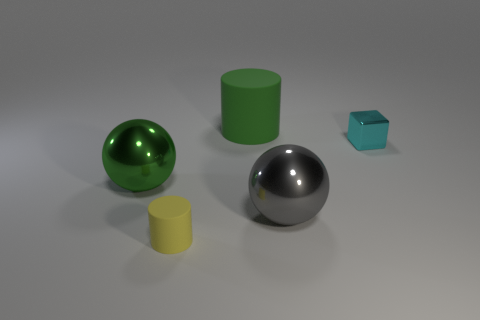There is a large green thing that is left of the small cylinder; what material is it?
Ensure brevity in your answer.  Metal. Is the material of the large green thing that is behind the cyan metallic thing the same as the small cyan cube?
Give a very brief answer. No. The green metal thing is what shape?
Keep it short and to the point. Sphere. There is a yellow matte cylinder in front of the green object right of the green metallic object; how many cylinders are to the left of it?
Offer a very short reply. 0. How many other objects are there of the same material as the gray sphere?
Your answer should be compact. 2. There is a gray object that is the same size as the green ball; what material is it?
Your answer should be very brief. Metal. Is the color of the sphere behind the big gray ball the same as the rubber cylinder behind the cyan block?
Provide a succinct answer. Yes. Is there another large rubber thing that has the same shape as the yellow matte thing?
Offer a very short reply. Yes. There is a shiny thing that is the same size as the gray shiny ball; what is its shape?
Keep it short and to the point. Sphere. How many large spheres have the same color as the large cylinder?
Your answer should be very brief. 1. 